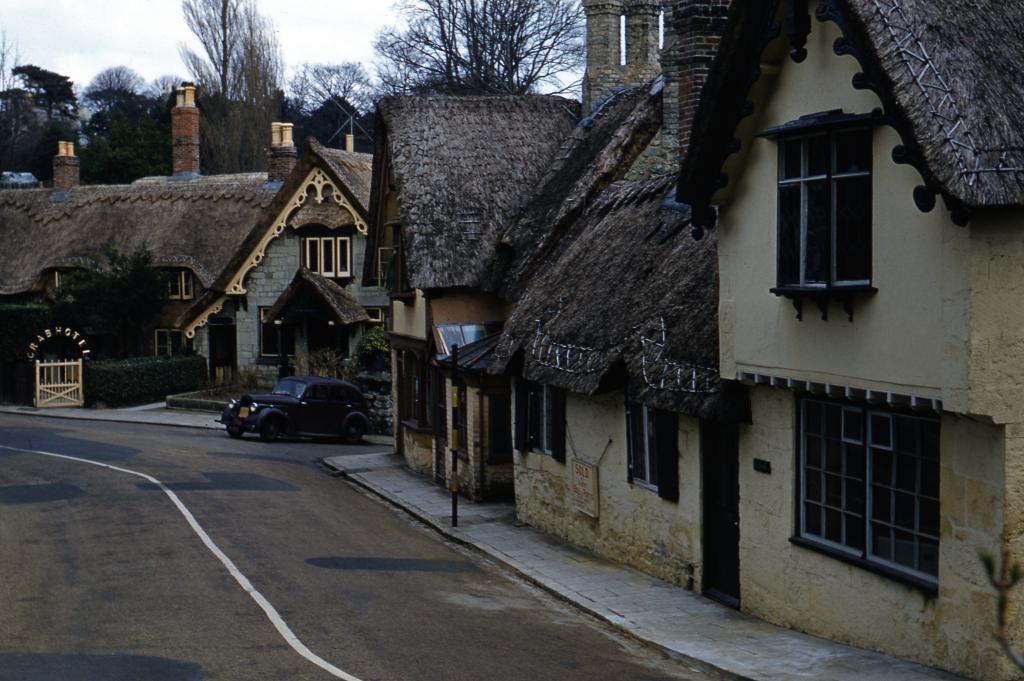How would you summarize this image in a sentence or two? In the image there is a road on the left side, on the right side there are homes with a car in the middle and behind it there are trees and above its sky. 